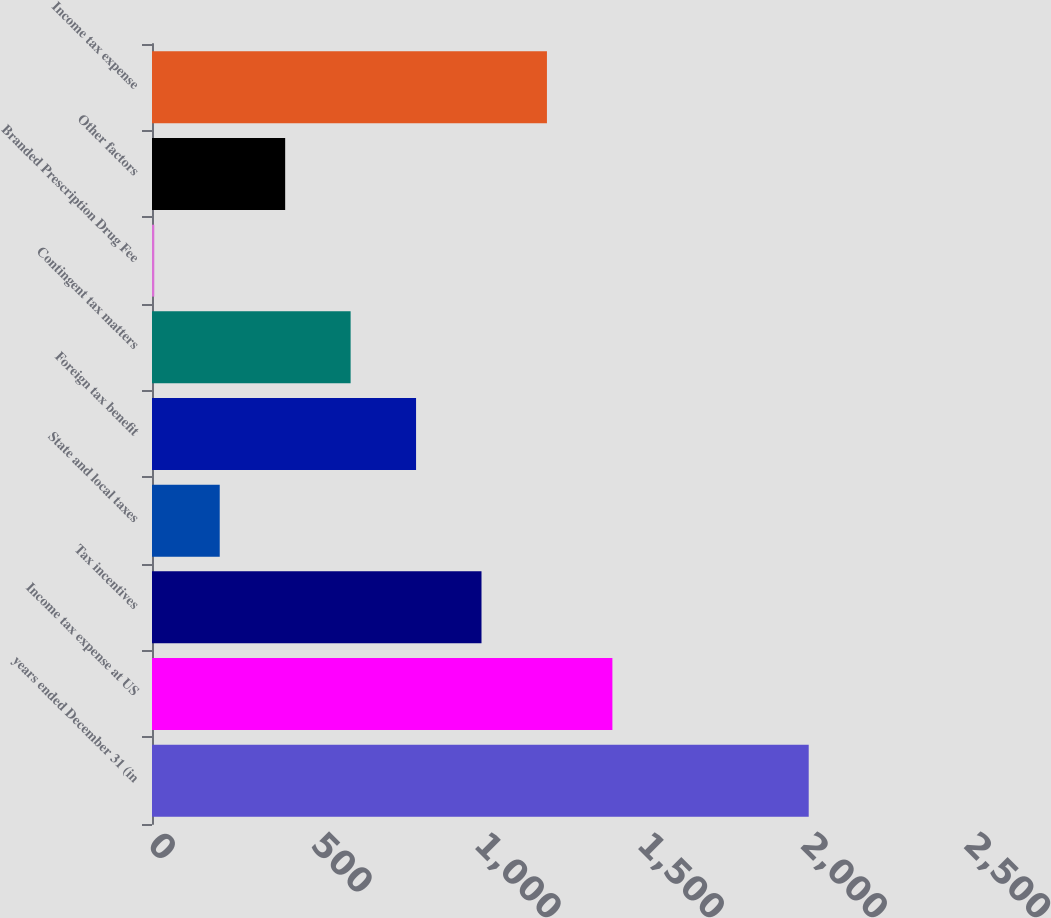Convert chart. <chart><loc_0><loc_0><loc_500><loc_500><bar_chart><fcel>years ended December 31 (in<fcel>Income tax expense at US<fcel>Tax incentives<fcel>State and local taxes<fcel>Foreign tax benefit<fcel>Contingent tax matters<fcel>Branded Prescription Drug Fee<fcel>Other factors<fcel>Income tax expense<nl><fcel>2012<fcel>1410.5<fcel>1009.5<fcel>207.5<fcel>809<fcel>608.5<fcel>7<fcel>408<fcel>1210<nl></chart> 